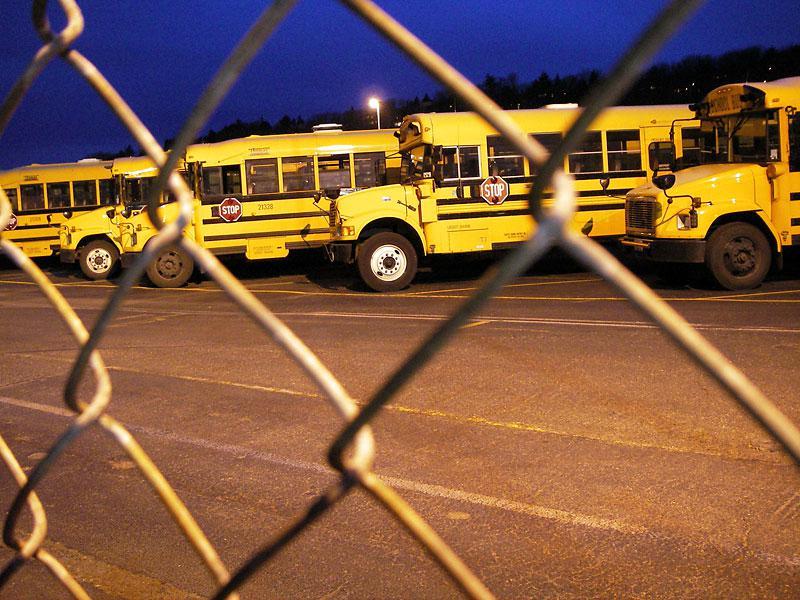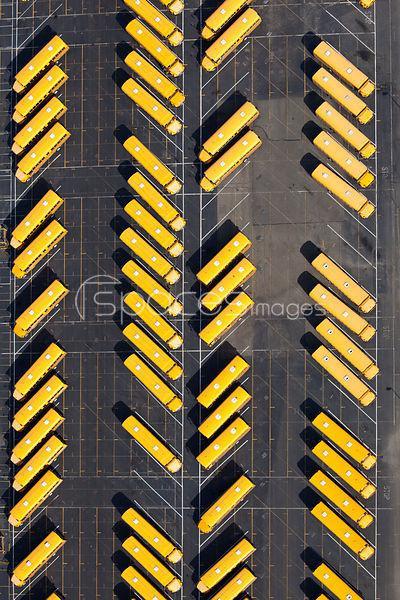The first image is the image on the left, the second image is the image on the right. Given the left and right images, does the statement "Words are written across the side of a school bus in the image on the right." hold true? Answer yes or no. No. The first image is the image on the left, the second image is the image on the right. Evaluate the accuracy of this statement regarding the images: "The right image contains an aerial view of a school bus parking lot.". Is it true? Answer yes or no. Yes. 